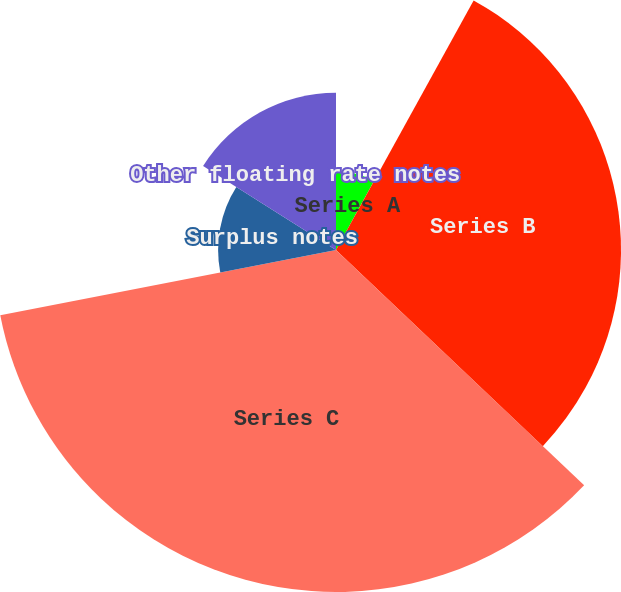Convert chart to OTSL. <chart><loc_0><loc_0><loc_500><loc_500><pie_chart><fcel>Series A<fcel>Series B<fcel>Series C<fcel>Surplus notes<fcel>Other floating rate notes<nl><fcel>8.02%<fcel>29.06%<fcel>34.87%<fcel>12.02%<fcel>16.03%<nl></chart> 